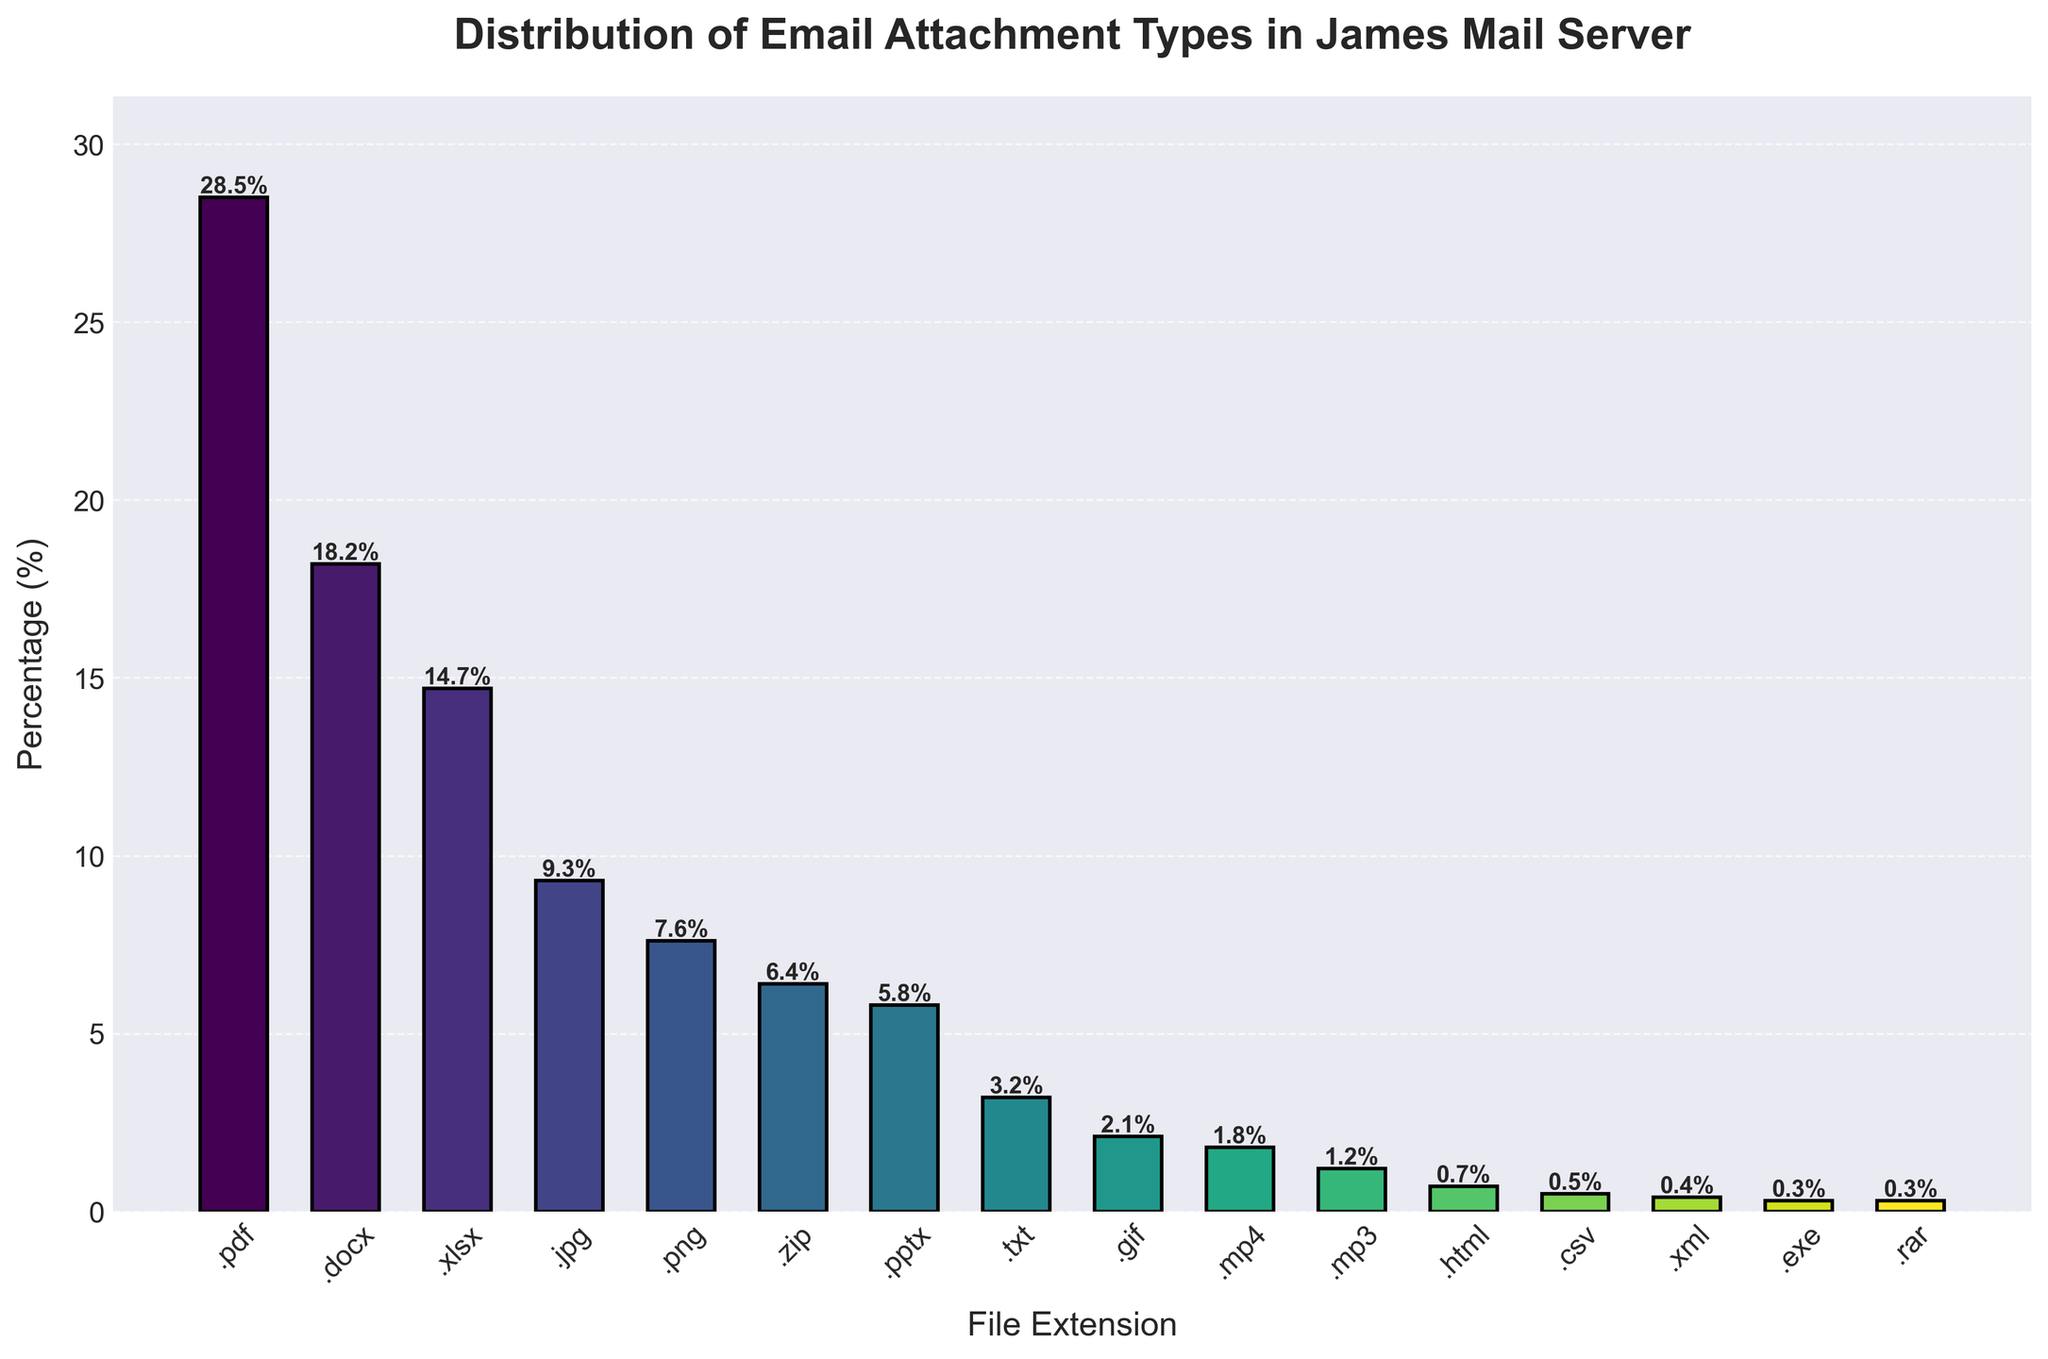What is the most common email attachment type? The highest bar represents the most common email attachment type. The .pdf bar is the tallest at 28.5%.
Answer: .pdf Which file extension has the lowest percentage of email attachments? The shortest bar indicates the lowest percentage. The .exe and .rar bars are the smallest at 0.3%.
Answer: .exe, .rar How much more frequent are .pdf attachments compared to .docx attachments? The .pdf percentage is 28.5% and the .docx percentage is 18.2%. Subtract 18.2 from 28.5.
Answer: 10.3% Are .jpeg attachments more or less common than .xlsx attachments? Compare the heights of the .jpeg (9.3%) and .xlsx (14.7%) bars.
Answer: Less common What is the total percentage of image attachment types (.jpeg, .png, .gif)? Add the percentages: .jpeg (9.3%), .png (7.6%), .gif (2.1%). Sum them.
Answer: 19% Which has a higher percentage, .zip or .pptx attachments? Compare the heights of the .zip (6.4%) and .pptx (5.8%) bars.
Answer: .zip What is the combined percentage of text and HTML attachment types (.txt and .html)? Add the percentages: .txt (3.2%) and .html (0.7%). Sum them.
Answer: 3.9% By how much does the percentage of .docx attachments exceed that of .mp4 attachments? Subtract the .mp4 percentage (1.8%) from the .docx percentage (18.2%).
Answer: 16.4% What is the average percentage of the three most common attachment types? Take the percentages of the top three types: .pdf (28.5%), .docx (18.2%), and .xlsx (14.7%). Calculate their average: (28.5 + 18.2 + 14.7) / 3.
Answer: 20.5% Which type appears exactly half as frequently as .xlsx attachments? Identify the bar with half the .xlsx percentage (14.7% / 2 = 7.35%). The closest value is .png with 7.6%.
Answer: .png 